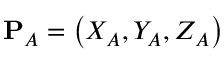Convert formula to latex. <formula><loc_0><loc_0><loc_500><loc_500>P _ { A } = \left ( X _ { A } , Y _ { A } , Z _ { A } \right )</formula> 